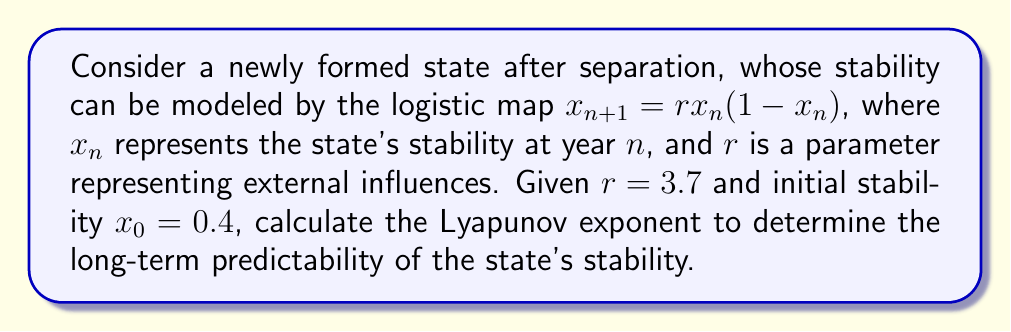Show me your answer to this math problem. To calculate the Lyapunov exponent for the logistic map:

1. The formula for the Lyapunov exponent $\lambda$ is:

   $$\lambda = \lim_{N \to \infty} \frac{1}{N} \sum_{n=0}^{N-1} \ln|f'(x_n)|$$

   where $f'(x_n)$ is the derivative of the logistic map.

2. For the logistic map $f(x) = rx(1-x)$, the derivative is:
   
   $$f'(x) = r(1-2x)$$

3. We need to iterate the map and calculate $\ln|f'(x_n)|$ for each iteration:

   Iteration 0: $x_0 = 0.4$
   $\ln|f'(x_0)| = \ln|3.7(1-2(0.4))| = \ln 0.74 = -0.3011$

   Iteration 1: $x_1 = 3.7(0.4)(1-0.4) = 0.888$
   $\ln|f'(x_1)| = \ln|3.7(1-2(0.888))| = \ln 2.8856 = 1.0598$

   Continue this process for many iterations (e.g., 1000).

4. Sum all the $\ln|f'(x_n)|$ values and divide by the number of iterations:

   $$\lambda \approx \frac{1}{1000} \sum_{n=0}^{999} \ln|3.7(1-2x_n)|$$

5. Using a computer to perform these calculations, we find:

   $$\lambda \approx 0.3574$$

This positive Lyapunov exponent indicates chaotic behavior, suggesting long-term unpredictability in the stability of the newly formed state.
Answer: $\lambda \approx 0.3574$ 